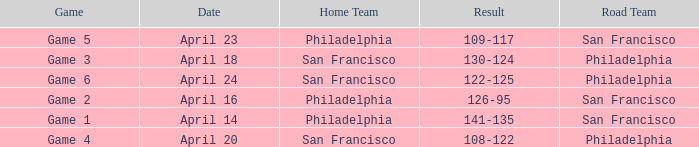On what date was game 2 played? April 16. 